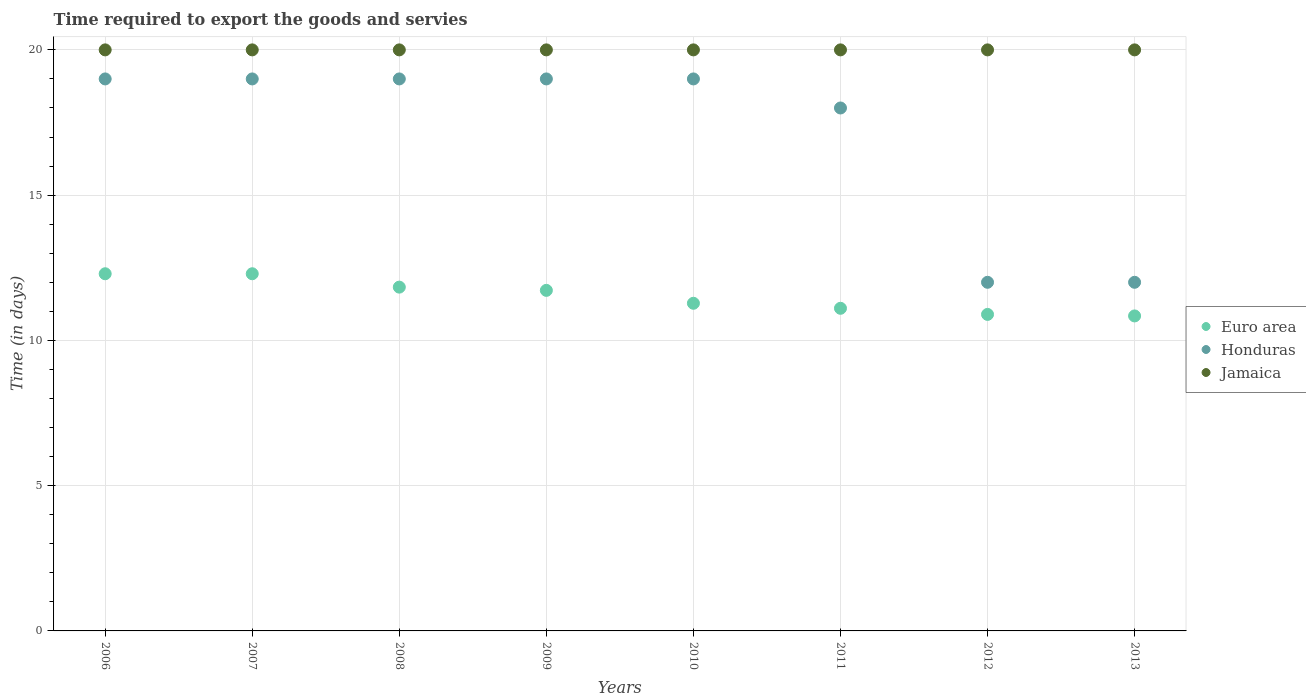How many different coloured dotlines are there?
Your answer should be compact. 3. What is the number of days required to export the goods and services in Jamaica in 2008?
Give a very brief answer. 20. Across all years, what is the maximum number of days required to export the goods and services in Honduras?
Give a very brief answer. 19. Across all years, what is the minimum number of days required to export the goods and services in Honduras?
Provide a succinct answer. 12. In which year was the number of days required to export the goods and services in Euro area minimum?
Keep it short and to the point. 2013. What is the total number of days required to export the goods and services in Jamaica in the graph?
Offer a terse response. 160. What is the difference between the number of days required to export the goods and services in Honduras in 2008 and that in 2012?
Provide a succinct answer. 7. What is the difference between the number of days required to export the goods and services in Jamaica in 2007 and the number of days required to export the goods and services in Euro area in 2008?
Provide a short and direct response. 8.17. What is the average number of days required to export the goods and services in Euro area per year?
Offer a very short reply. 11.53. In the year 2006, what is the difference between the number of days required to export the goods and services in Euro area and number of days required to export the goods and services in Honduras?
Offer a terse response. -6.71. In how many years, is the number of days required to export the goods and services in Jamaica greater than 3 days?
Give a very brief answer. 8. What is the difference between the highest and the lowest number of days required to export the goods and services in Honduras?
Make the answer very short. 7. In how many years, is the number of days required to export the goods and services in Jamaica greater than the average number of days required to export the goods and services in Jamaica taken over all years?
Give a very brief answer. 0. Is it the case that in every year, the sum of the number of days required to export the goods and services in Euro area and number of days required to export the goods and services in Jamaica  is greater than the number of days required to export the goods and services in Honduras?
Offer a terse response. Yes. Does the number of days required to export the goods and services in Honduras monotonically increase over the years?
Your answer should be compact. No. Is the number of days required to export the goods and services in Euro area strictly less than the number of days required to export the goods and services in Jamaica over the years?
Provide a short and direct response. Yes. How many dotlines are there?
Make the answer very short. 3. What is the difference between two consecutive major ticks on the Y-axis?
Your answer should be compact. 5. Are the values on the major ticks of Y-axis written in scientific E-notation?
Offer a very short reply. No. Does the graph contain grids?
Ensure brevity in your answer.  Yes. Where does the legend appear in the graph?
Your response must be concise. Center right. How many legend labels are there?
Provide a short and direct response. 3. How are the legend labels stacked?
Give a very brief answer. Vertical. What is the title of the graph?
Offer a terse response. Time required to export the goods and servies. What is the label or title of the Y-axis?
Your answer should be compact. Time (in days). What is the Time (in days) of Euro area in 2006?
Offer a terse response. 12.29. What is the Time (in days) in Euro area in 2007?
Provide a succinct answer. 12.29. What is the Time (in days) in Euro area in 2008?
Make the answer very short. 11.83. What is the Time (in days) in Jamaica in 2008?
Provide a short and direct response. 20. What is the Time (in days) of Euro area in 2009?
Give a very brief answer. 11.72. What is the Time (in days) of Honduras in 2009?
Your answer should be very brief. 19. What is the Time (in days) of Jamaica in 2009?
Give a very brief answer. 20. What is the Time (in days) in Euro area in 2010?
Your answer should be very brief. 11.28. What is the Time (in days) of Honduras in 2010?
Keep it short and to the point. 19. What is the Time (in days) in Euro area in 2011?
Provide a succinct answer. 11.11. What is the Time (in days) of Jamaica in 2011?
Provide a short and direct response. 20. What is the Time (in days) of Euro area in 2012?
Your answer should be compact. 10.89. What is the Time (in days) of Honduras in 2012?
Your response must be concise. 12. What is the Time (in days) in Euro area in 2013?
Your response must be concise. 10.84. Across all years, what is the maximum Time (in days) of Euro area?
Keep it short and to the point. 12.29. Across all years, what is the maximum Time (in days) in Honduras?
Your response must be concise. 19. Across all years, what is the minimum Time (in days) in Euro area?
Your response must be concise. 10.84. Across all years, what is the minimum Time (in days) of Jamaica?
Give a very brief answer. 20. What is the total Time (in days) in Euro area in the graph?
Provide a short and direct response. 92.26. What is the total Time (in days) in Honduras in the graph?
Offer a very short reply. 137. What is the total Time (in days) of Jamaica in the graph?
Give a very brief answer. 160. What is the difference between the Time (in days) of Euro area in 2006 and that in 2007?
Your answer should be very brief. 0. What is the difference between the Time (in days) of Jamaica in 2006 and that in 2007?
Offer a terse response. 0. What is the difference between the Time (in days) in Euro area in 2006 and that in 2008?
Provide a succinct answer. 0.46. What is the difference between the Time (in days) of Euro area in 2006 and that in 2009?
Offer a terse response. 0.57. What is the difference between the Time (in days) of Jamaica in 2006 and that in 2009?
Ensure brevity in your answer.  0. What is the difference between the Time (in days) in Euro area in 2006 and that in 2010?
Ensure brevity in your answer.  1.02. What is the difference between the Time (in days) in Honduras in 2006 and that in 2010?
Your answer should be compact. 0. What is the difference between the Time (in days) of Euro area in 2006 and that in 2011?
Ensure brevity in your answer.  1.19. What is the difference between the Time (in days) in Euro area in 2006 and that in 2012?
Give a very brief answer. 1.4. What is the difference between the Time (in days) in Honduras in 2006 and that in 2012?
Provide a succinct answer. 7. What is the difference between the Time (in days) in Jamaica in 2006 and that in 2012?
Give a very brief answer. 0. What is the difference between the Time (in days) in Euro area in 2006 and that in 2013?
Offer a very short reply. 1.45. What is the difference between the Time (in days) in Honduras in 2006 and that in 2013?
Your answer should be very brief. 7. What is the difference between the Time (in days) of Euro area in 2007 and that in 2008?
Your answer should be very brief. 0.46. What is the difference between the Time (in days) in Honduras in 2007 and that in 2008?
Keep it short and to the point. 0. What is the difference between the Time (in days) of Euro area in 2007 and that in 2009?
Your answer should be very brief. 0.57. What is the difference between the Time (in days) of Honduras in 2007 and that in 2009?
Give a very brief answer. 0. What is the difference between the Time (in days) in Euro area in 2007 and that in 2010?
Your response must be concise. 1.02. What is the difference between the Time (in days) of Honduras in 2007 and that in 2010?
Make the answer very short. 0. What is the difference between the Time (in days) of Jamaica in 2007 and that in 2010?
Make the answer very short. 0. What is the difference between the Time (in days) in Euro area in 2007 and that in 2011?
Offer a very short reply. 1.19. What is the difference between the Time (in days) in Euro area in 2007 and that in 2012?
Make the answer very short. 1.4. What is the difference between the Time (in days) of Euro area in 2007 and that in 2013?
Ensure brevity in your answer.  1.45. What is the difference between the Time (in days) of Euro area in 2008 and that in 2009?
Your answer should be compact. 0.11. What is the difference between the Time (in days) of Euro area in 2008 and that in 2010?
Give a very brief answer. 0.56. What is the difference between the Time (in days) of Euro area in 2008 and that in 2011?
Offer a very short reply. 0.73. What is the difference between the Time (in days) of Honduras in 2008 and that in 2011?
Ensure brevity in your answer.  1. What is the difference between the Time (in days) of Jamaica in 2008 and that in 2011?
Your answer should be very brief. 0. What is the difference between the Time (in days) of Euro area in 2008 and that in 2012?
Offer a terse response. 0.94. What is the difference between the Time (in days) of Jamaica in 2008 and that in 2012?
Provide a succinct answer. 0. What is the difference between the Time (in days) in Honduras in 2008 and that in 2013?
Provide a short and direct response. 7. What is the difference between the Time (in days) in Euro area in 2009 and that in 2010?
Provide a succinct answer. 0.44. What is the difference between the Time (in days) of Honduras in 2009 and that in 2010?
Offer a terse response. 0. What is the difference between the Time (in days) in Jamaica in 2009 and that in 2010?
Your response must be concise. 0. What is the difference between the Time (in days) of Euro area in 2009 and that in 2011?
Your answer should be compact. 0.62. What is the difference between the Time (in days) in Honduras in 2009 and that in 2011?
Offer a very short reply. 1. What is the difference between the Time (in days) in Euro area in 2009 and that in 2012?
Keep it short and to the point. 0.83. What is the difference between the Time (in days) in Honduras in 2009 and that in 2012?
Offer a terse response. 7. What is the difference between the Time (in days) in Euro area in 2009 and that in 2013?
Ensure brevity in your answer.  0.88. What is the difference between the Time (in days) in Jamaica in 2009 and that in 2013?
Make the answer very short. 0. What is the difference between the Time (in days) in Euro area in 2010 and that in 2011?
Provide a short and direct response. 0.17. What is the difference between the Time (in days) in Euro area in 2010 and that in 2012?
Provide a short and direct response. 0.38. What is the difference between the Time (in days) of Jamaica in 2010 and that in 2012?
Keep it short and to the point. 0. What is the difference between the Time (in days) in Euro area in 2010 and that in 2013?
Your answer should be compact. 0.44. What is the difference between the Time (in days) in Honduras in 2010 and that in 2013?
Make the answer very short. 7. What is the difference between the Time (in days) of Jamaica in 2010 and that in 2013?
Offer a terse response. 0. What is the difference between the Time (in days) in Euro area in 2011 and that in 2012?
Your answer should be compact. 0.21. What is the difference between the Time (in days) in Euro area in 2011 and that in 2013?
Your answer should be very brief. 0.26. What is the difference between the Time (in days) in Euro area in 2012 and that in 2013?
Give a very brief answer. 0.05. What is the difference between the Time (in days) in Honduras in 2012 and that in 2013?
Your response must be concise. 0. What is the difference between the Time (in days) in Euro area in 2006 and the Time (in days) in Honduras in 2007?
Your answer should be compact. -6.71. What is the difference between the Time (in days) of Euro area in 2006 and the Time (in days) of Jamaica in 2007?
Give a very brief answer. -7.71. What is the difference between the Time (in days) of Euro area in 2006 and the Time (in days) of Honduras in 2008?
Your answer should be very brief. -6.71. What is the difference between the Time (in days) of Euro area in 2006 and the Time (in days) of Jamaica in 2008?
Provide a succinct answer. -7.71. What is the difference between the Time (in days) in Euro area in 2006 and the Time (in days) in Honduras in 2009?
Offer a terse response. -6.71. What is the difference between the Time (in days) of Euro area in 2006 and the Time (in days) of Jamaica in 2009?
Offer a terse response. -7.71. What is the difference between the Time (in days) in Euro area in 2006 and the Time (in days) in Honduras in 2010?
Make the answer very short. -6.71. What is the difference between the Time (in days) in Euro area in 2006 and the Time (in days) in Jamaica in 2010?
Provide a short and direct response. -7.71. What is the difference between the Time (in days) in Honduras in 2006 and the Time (in days) in Jamaica in 2010?
Ensure brevity in your answer.  -1. What is the difference between the Time (in days) in Euro area in 2006 and the Time (in days) in Honduras in 2011?
Offer a terse response. -5.71. What is the difference between the Time (in days) of Euro area in 2006 and the Time (in days) of Jamaica in 2011?
Provide a succinct answer. -7.71. What is the difference between the Time (in days) in Euro area in 2006 and the Time (in days) in Honduras in 2012?
Provide a short and direct response. 0.29. What is the difference between the Time (in days) in Euro area in 2006 and the Time (in days) in Jamaica in 2012?
Ensure brevity in your answer.  -7.71. What is the difference between the Time (in days) of Honduras in 2006 and the Time (in days) of Jamaica in 2012?
Give a very brief answer. -1. What is the difference between the Time (in days) of Euro area in 2006 and the Time (in days) of Honduras in 2013?
Your answer should be very brief. 0.29. What is the difference between the Time (in days) in Euro area in 2006 and the Time (in days) in Jamaica in 2013?
Make the answer very short. -7.71. What is the difference between the Time (in days) of Honduras in 2006 and the Time (in days) of Jamaica in 2013?
Ensure brevity in your answer.  -1. What is the difference between the Time (in days) in Euro area in 2007 and the Time (in days) in Honduras in 2008?
Make the answer very short. -6.71. What is the difference between the Time (in days) in Euro area in 2007 and the Time (in days) in Jamaica in 2008?
Provide a short and direct response. -7.71. What is the difference between the Time (in days) in Honduras in 2007 and the Time (in days) in Jamaica in 2008?
Your answer should be very brief. -1. What is the difference between the Time (in days) in Euro area in 2007 and the Time (in days) in Honduras in 2009?
Your answer should be very brief. -6.71. What is the difference between the Time (in days) in Euro area in 2007 and the Time (in days) in Jamaica in 2009?
Keep it short and to the point. -7.71. What is the difference between the Time (in days) of Euro area in 2007 and the Time (in days) of Honduras in 2010?
Provide a succinct answer. -6.71. What is the difference between the Time (in days) in Euro area in 2007 and the Time (in days) in Jamaica in 2010?
Your answer should be compact. -7.71. What is the difference between the Time (in days) of Euro area in 2007 and the Time (in days) of Honduras in 2011?
Keep it short and to the point. -5.71. What is the difference between the Time (in days) of Euro area in 2007 and the Time (in days) of Jamaica in 2011?
Offer a terse response. -7.71. What is the difference between the Time (in days) in Honduras in 2007 and the Time (in days) in Jamaica in 2011?
Ensure brevity in your answer.  -1. What is the difference between the Time (in days) in Euro area in 2007 and the Time (in days) in Honduras in 2012?
Ensure brevity in your answer.  0.29. What is the difference between the Time (in days) in Euro area in 2007 and the Time (in days) in Jamaica in 2012?
Make the answer very short. -7.71. What is the difference between the Time (in days) in Honduras in 2007 and the Time (in days) in Jamaica in 2012?
Your answer should be very brief. -1. What is the difference between the Time (in days) of Euro area in 2007 and the Time (in days) of Honduras in 2013?
Keep it short and to the point. 0.29. What is the difference between the Time (in days) in Euro area in 2007 and the Time (in days) in Jamaica in 2013?
Offer a terse response. -7.71. What is the difference between the Time (in days) in Euro area in 2008 and the Time (in days) in Honduras in 2009?
Provide a short and direct response. -7.17. What is the difference between the Time (in days) of Euro area in 2008 and the Time (in days) of Jamaica in 2009?
Ensure brevity in your answer.  -8.17. What is the difference between the Time (in days) of Honduras in 2008 and the Time (in days) of Jamaica in 2009?
Your answer should be compact. -1. What is the difference between the Time (in days) of Euro area in 2008 and the Time (in days) of Honduras in 2010?
Offer a very short reply. -7.17. What is the difference between the Time (in days) of Euro area in 2008 and the Time (in days) of Jamaica in 2010?
Your answer should be very brief. -8.17. What is the difference between the Time (in days) of Honduras in 2008 and the Time (in days) of Jamaica in 2010?
Your answer should be compact. -1. What is the difference between the Time (in days) in Euro area in 2008 and the Time (in days) in Honduras in 2011?
Offer a terse response. -6.17. What is the difference between the Time (in days) in Euro area in 2008 and the Time (in days) in Jamaica in 2011?
Provide a succinct answer. -8.17. What is the difference between the Time (in days) in Euro area in 2008 and the Time (in days) in Honduras in 2012?
Your response must be concise. -0.17. What is the difference between the Time (in days) in Euro area in 2008 and the Time (in days) in Jamaica in 2012?
Offer a very short reply. -8.17. What is the difference between the Time (in days) in Honduras in 2008 and the Time (in days) in Jamaica in 2012?
Give a very brief answer. -1. What is the difference between the Time (in days) of Euro area in 2008 and the Time (in days) of Honduras in 2013?
Your answer should be compact. -0.17. What is the difference between the Time (in days) in Euro area in 2008 and the Time (in days) in Jamaica in 2013?
Offer a terse response. -8.17. What is the difference between the Time (in days) in Honduras in 2008 and the Time (in days) in Jamaica in 2013?
Keep it short and to the point. -1. What is the difference between the Time (in days) of Euro area in 2009 and the Time (in days) of Honduras in 2010?
Offer a very short reply. -7.28. What is the difference between the Time (in days) in Euro area in 2009 and the Time (in days) in Jamaica in 2010?
Make the answer very short. -8.28. What is the difference between the Time (in days) of Honduras in 2009 and the Time (in days) of Jamaica in 2010?
Provide a succinct answer. -1. What is the difference between the Time (in days) of Euro area in 2009 and the Time (in days) of Honduras in 2011?
Your answer should be compact. -6.28. What is the difference between the Time (in days) of Euro area in 2009 and the Time (in days) of Jamaica in 2011?
Ensure brevity in your answer.  -8.28. What is the difference between the Time (in days) in Honduras in 2009 and the Time (in days) in Jamaica in 2011?
Your answer should be compact. -1. What is the difference between the Time (in days) of Euro area in 2009 and the Time (in days) of Honduras in 2012?
Offer a terse response. -0.28. What is the difference between the Time (in days) of Euro area in 2009 and the Time (in days) of Jamaica in 2012?
Ensure brevity in your answer.  -8.28. What is the difference between the Time (in days) of Honduras in 2009 and the Time (in days) of Jamaica in 2012?
Your response must be concise. -1. What is the difference between the Time (in days) of Euro area in 2009 and the Time (in days) of Honduras in 2013?
Your response must be concise. -0.28. What is the difference between the Time (in days) in Euro area in 2009 and the Time (in days) in Jamaica in 2013?
Provide a short and direct response. -8.28. What is the difference between the Time (in days) of Euro area in 2010 and the Time (in days) of Honduras in 2011?
Provide a succinct answer. -6.72. What is the difference between the Time (in days) of Euro area in 2010 and the Time (in days) of Jamaica in 2011?
Keep it short and to the point. -8.72. What is the difference between the Time (in days) in Honduras in 2010 and the Time (in days) in Jamaica in 2011?
Make the answer very short. -1. What is the difference between the Time (in days) in Euro area in 2010 and the Time (in days) in Honduras in 2012?
Offer a very short reply. -0.72. What is the difference between the Time (in days) in Euro area in 2010 and the Time (in days) in Jamaica in 2012?
Your answer should be very brief. -8.72. What is the difference between the Time (in days) in Euro area in 2010 and the Time (in days) in Honduras in 2013?
Your response must be concise. -0.72. What is the difference between the Time (in days) in Euro area in 2010 and the Time (in days) in Jamaica in 2013?
Make the answer very short. -8.72. What is the difference between the Time (in days) of Honduras in 2010 and the Time (in days) of Jamaica in 2013?
Ensure brevity in your answer.  -1. What is the difference between the Time (in days) in Euro area in 2011 and the Time (in days) in Honduras in 2012?
Ensure brevity in your answer.  -0.89. What is the difference between the Time (in days) of Euro area in 2011 and the Time (in days) of Jamaica in 2012?
Offer a terse response. -8.89. What is the difference between the Time (in days) in Honduras in 2011 and the Time (in days) in Jamaica in 2012?
Offer a terse response. -2. What is the difference between the Time (in days) of Euro area in 2011 and the Time (in days) of Honduras in 2013?
Your answer should be very brief. -0.89. What is the difference between the Time (in days) of Euro area in 2011 and the Time (in days) of Jamaica in 2013?
Keep it short and to the point. -8.89. What is the difference between the Time (in days) of Honduras in 2011 and the Time (in days) of Jamaica in 2013?
Offer a terse response. -2. What is the difference between the Time (in days) of Euro area in 2012 and the Time (in days) of Honduras in 2013?
Give a very brief answer. -1.11. What is the difference between the Time (in days) in Euro area in 2012 and the Time (in days) in Jamaica in 2013?
Your response must be concise. -9.11. What is the average Time (in days) of Euro area per year?
Keep it short and to the point. 11.53. What is the average Time (in days) in Honduras per year?
Offer a very short reply. 17.12. In the year 2006, what is the difference between the Time (in days) in Euro area and Time (in days) in Honduras?
Your answer should be compact. -6.71. In the year 2006, what is the difference between the Time (in days) of Euro area and Time (in days) of Jamaica?
Provide a succinct answer. -7.71. In the year 2006, what is the difference between the Time (in days) in Honduras and Time (in days) in Jamaica?
Offer a terse response. -1. In the year 2007, what is the difference between the Time (in days) of Euro area and Time (in days) of Honduras?
Your answer should be very brief. -6.71. In the year 2007, what is the difference between the Time (in days) in Euro area and Time (in days) in Jamaica?
Ensure brevity in your answer.  -7.71. In the year 2008, what is the difference between the Time (in days) of Euro area and Time (in days) of Honduras?
Provide a succinct answer. -7.17. In the year 2008, what is the difference between the Time (in days) in Euro area and Time (in days) in Jamaica?
Offer a terse response. -8.17. In the year 2009, what is the difference between the Time (in days) of Euro area and Time (in days) of Honduras?
Make the answer very short. -7.28. In the year 2009, what is the difference between the Time (in days) of Euro area and Time (in days) of Jamaica?
Offer a very short reply. -8.28. In the year 2010, what is the difference between the Time (in days) of Euro area and Time (in days) of Honduras?
Make the answer very short. -7.72. In the year 2010, what is the difference between the Time (in days) of Euro area and Time (in days) of Jamaica?
Provide a succinct answer. -8.72. In the year 2011, what is the difference between the Time (in days) of Euro area and Time (in days) of Honduras?
Provide a short and direct response. -6.89. In the year 2011, what is the difference between the Time (in days) in Euro area and Time (in days) in Jamaica?
Offer a terse response. -8.89. In the year 2012, what is the difference between the Time (in days) in Euro area and Time (in days) in Honduras?
Give a very brief answer. -1.11. In the year 2012, what is the difference between the Time (in days) of Euro area and Time (in days) of Jamaica?
Ensure brevity in your answer.  -9.11. In the year 2012, what is the difference between the Time (in days) in Honduras and Time (in days) in Jamaica?
Keep it short and to the point. -8. In the year 2013, what is the difference between the Time (in days) of Euro area and Time (in days) of Honduras?
Your answer should be very brief. -1.16. In the year 2013, what is the difference between the Time (in days) in Euro area and Time (in days) in Jamaica?
Your answer should be compact. -9.16. What is the ratio of the Time (in days) in Euro area in 2006 to that in 2007?
Offer a very short reply. 1. What is the ratio of the Time (in days) of Honduras in 2006 to that in 2007?
Your answer should be very brief. 1. What is the ratio of the Time (in days) in Jamaica in 2006 to that in 2007?
Provide a short and direct response. 1. What is the ratio of the Time (in days) in Euro area in 2006 to that in 2008?
Provide a short and direct response. 1.04. What is the ratio of the Time (in days) in Honduras in 2006 to that in 2008?
Your answer should be very brief. 1. What is the ratio of the Time (in days) of Euro area in 2006 to that in 2009?
Keep it short and to the point. 1.05. What is the ratio of the Time (in days) in Honduras in 2006 to that in 2009?
Your answer should be very brief. 1. What is the ratio of the Time (in days) of Jamaica in 2006 to that in 2009?
Your answer should be compact. 1. What is the ratio of the Time (in days) in Euro area in 2006 to that in 2010?
Provide a succinct answer. 1.09. What is the ratio of the Time (in days) in Honduras in 2006 to that in 2010?
Provide a succinct answer. 1. What is the ratio of the Time (in days) of Jamaica in 2006 to that in 2010?
Give a very brief answer. 1. What is the ratio of the Time (in days) in Euro area in 2006 to that in 2011?
Give a very brief answer. 1.11. What is the ratio of the Time (in days) of Honduras in 2006 to that in 2011?
Keep it short and to the point. 1.06. What is the ratio of the Time (in days) of Euro area in 2006 to that in 2012?
Ensure brevity in your answer.  1.13. What is the ratio of the Time (in days) in Honduras in 2006 to that in 2012?
Make the answer very short. 1.58. What is the ratio of the Time (in days) of Euro area in 2006 to that in 2013?
Make the answer very short. 1.13. What is the ratio of the Time (in days) of Honduras in 2006 to that in 2013?
Provide a succinct answer. 1.58. What is the ratio of the Time (in days) of Euro area in 2007 to that in 2008?
Your answer should be compact. 1.04. What is the ratio of the Time (in days) in Honduras in 2007 to that in 2008?
Offer a very short reply. 1. What is the ratio of the Time (in days) of Jamaica in 2007 to that in 2008?
Your response must be concise. 1. What is the ratio of the Time (in days) of Euro area in 2007 to that in 2009?
Offer a terse response. 1.05. What is the ratio of the Time (in days) in Honduras in 2007 to that in 2009?
Your answer should be very brief. 1. What is the ratio of the Time (in days) of Jamaica in 2007 to that in 2009?
Your response must be concise. 1. What is the ratio of the Time (in days) in Euro area in 2007 to that in 2010?
Ensure brevity in your answer.  1.09. What is the ratio of the Time (in days) in Honduras in 2007 to that in 2010?
Provide a succinct answer. 1. What is the ratio of the Time (in days) of Euro area in 2007 to that in 2011?
Ensure brevity in your answer.  1.11. What is the ratio of the Time (in days) of Honduras in 2007 to that in 2011?
Your answer should be very brief. 1.06. What is the ratio of the Time (in days) in Euro area in 2007 to that in 2012?
Keep it short and to the point. 1.13. What is the ratio of the Time (in days) of Honduras in 2007 to that in 2012?
Ensure brevity in your answer.  1.58. What is the ratio of the Time (in days) of Jamaica in 2007 to that in 2012?
Your response must be concise. 1. What is the ratio of the Time (in days) of Euro area in 2007 to that in 2013?
Ensure brevity in your answer.  1.13. What is the ratio of the Time (in days) of Honduras in 2007 to that in 2013?
Provide a short and direct response. 1.58. What is the ratio of the Time (in days) in Jamaica in 2007 to that in 2013?
Your response must be concise. 1. What is the ratio of the Time (in days) of Euro area in 2008 to that in 2009?
Provide a short and direct response. 1.01. What is the ratio of the Time (in days) of Jamaica in 2008 to that in 2009?
Keep it short and to the point. 1. What is the ratio of the Time (in days) in Euro area in 2008 to that in 2010?
Your response must be concise. 1.05. What is the ratio of the Time (in days) in Euro area in 2008 to that in 2011?
Your response must be concise. 1.07. What is the ratio of the Time (in days) of Honduras in 2008 to that in 2011?
Make the answer very short. 1.06. What is the ratio of the Time (in days) in Euro area in 2008 to that in 2012?
Offer a very short reply. 1.09. What is the ratio of the Time (in days) of Honduras in 2008 to that in 2012?
Keep it short and to the point. 1.58. What is the ratio of the Time (in days) of Euro area in 2008 to that in 2013?
Make the answer very short. 1.09. What is the ratio of the Time (in days) in Honduras in 2008 to that in 2013?
Ensure brevity in your answer.  1.58. What is the ratio of the Time (in days) of Euro area in 2009 to that in 2010?
Offer a terse response. 1.04. What is the ratio of the Time (in days) of Honduras in 2009 to that in 2010?
Provide a short and direct response. 1. What is the ratio of the Time (in days) of Euro area in 2009 to that in 2011?
Your response must be concise. 1.06. What is the ratio of the Time (in days) of Honduras in 2009 to that in 2011?
Your answer should be compact. 1.06. What is the ratio of the Time (in days) of Jamaica in 2009 to that in 2011?
Ensure brevity in your answer.  1. What is the ratio of the Time (in days) in Euro area in 2009 to that in 2012?
Your answer should be very brief. 1.08. What is the ratio of the Time (in days) in Honduras in 2009 to that in 2012?
Keep it short and to the point. 1.58. What is the ratio of the Time (in days) of Jamaica in 2009 to that in 2012?
Your answer should be compact. 1. What is the ratio of the Time (in days) in Euro area in 2009 to that in 2013?
Keep it short and to the point. 1.08. What is the ratio of the Time (in days) in Honduras in 2009 to that in 2013?
Keep it short and to the point. 1.58. What is the ratio of the Time (in days) in Euro area in 2010 to that in 2011?
Provide a short and direct response. 1.02. What is the ratio of the Time (in days) in Honduras in 2010 to that in 2011?
Ensure brevity in your answer.  1.06. What is the ratio of the Time (in days) of Euro area in 2010 to that in 2012?
Provide a succinct answer. 1.04. What is the ratio of the Time (in days) of Honduras in 2010 to that in 2012?
Provide a succinct answer. 1.58. What is the ratio of the Time (in days) of Jamaica in 2010 to that in 2012?
Give a very brief answer. 1. What is the ratio of the Time (in days) of Euro area in 2010 to that in 2013?
Make the answer very short. 1.04. What is the ratio of the Time (in days) of Honduras in 2010 to that in 2013?
Offer a terse response. 1.58. What is the ratio of the Time (in days) of Euro area in 2011 to that in 2012?
Your answer should be very brief. 1.02. What is the ratio of the Time (in days) of Euro area in 2011 to that in 2013?
Provide a succinct answer. 1.02. What is the ratio of the Time (in days) in Euro area in 2012 to that in 2013?
Provide a succinct answer. 1. What is the ratio of the Time (in days) of Honduras in 2012 to that in 2013?
Keep it short and to the point. 1. What is the ratio of the Time (in days) in Jamaica in 2012 to that in 2013?
Ensure brevity in your answer.  1. What is the difference between the highest and the lowest Time (in days) in Euro area?
Your answer should be compact. 1.45. What is the difference between the highest and the lowest Time (in days) of Jamaica?
Give a very brief answer. 0. 